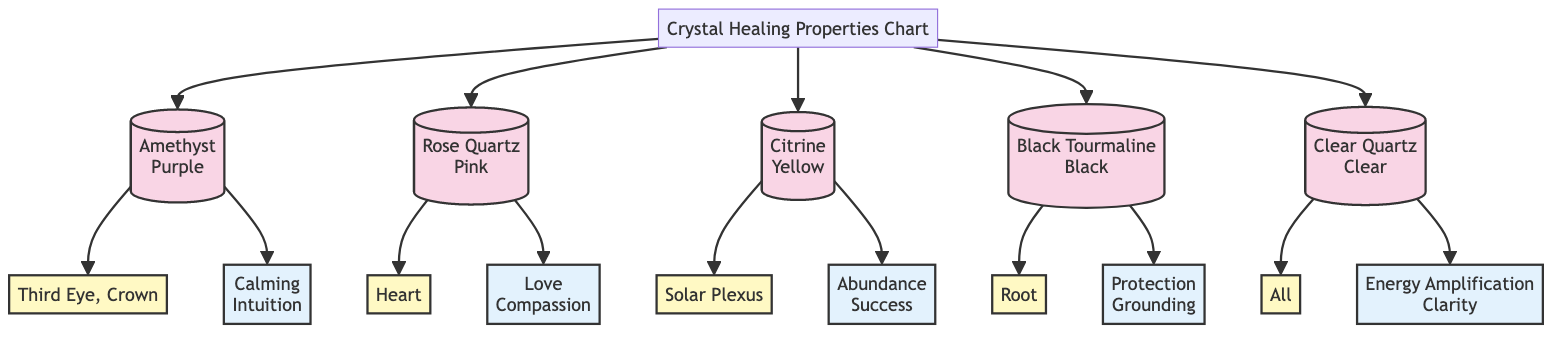What crystal is associated with the Third Eye and Crown chakras? The diagram shows Amethyst linked to both the Third Eye and Crown chakras, indicating its association with these energy centers.
Answer: Amethyst How many crystals are listed in the diagram? The diagram displays five different crystals: Amethyst, Rose Quartz, Citrine, Black Tourmaline, and Clear Quartz. Counting them gives a total of five.
Answer: 5 What is the metaphysical property of Clear Quartz? According to the diagram, Clear Quartz is associated with Energy Amplification and Clarity, as specified under its properties.
Answer: Energy Amplification, Clarity Which crystal represents love and compassion? The diagram links Rose Quartz to the property of Love and Compassion, indicating that this crystal embodies these qualities.
Answer: Rose Quartz Which crystal is associated with grounding? The diagram indicates Black Tourmaline is related to Protection and Grounding, showing its intended use for these purposes.
Answer: Black Tourmaline What chakra is Citrine associated with? The diagram shows that Citrine is associated with the Solar Plexus chakra, which is highlighted as its corresponding energy center.
Answer: Solar Plexus What are the properties of Amethyst? From the diagram, Amethyst has properties described as Calming and Intuition, clearly linking these qualities to this crystal.
Answer: Calming, Intuition Which crystal is associated with the Heart chakra? The diagram points to Rose Quartz being associated with the Heart chakra, labeling it explicitly in the chart.
Answer: Rose Quartz What color is Black Tourmaline? The diagram specifies that Black Tourmaline is represented with the color Black, directly labeling its appearance in the chart.
Answer: Black 